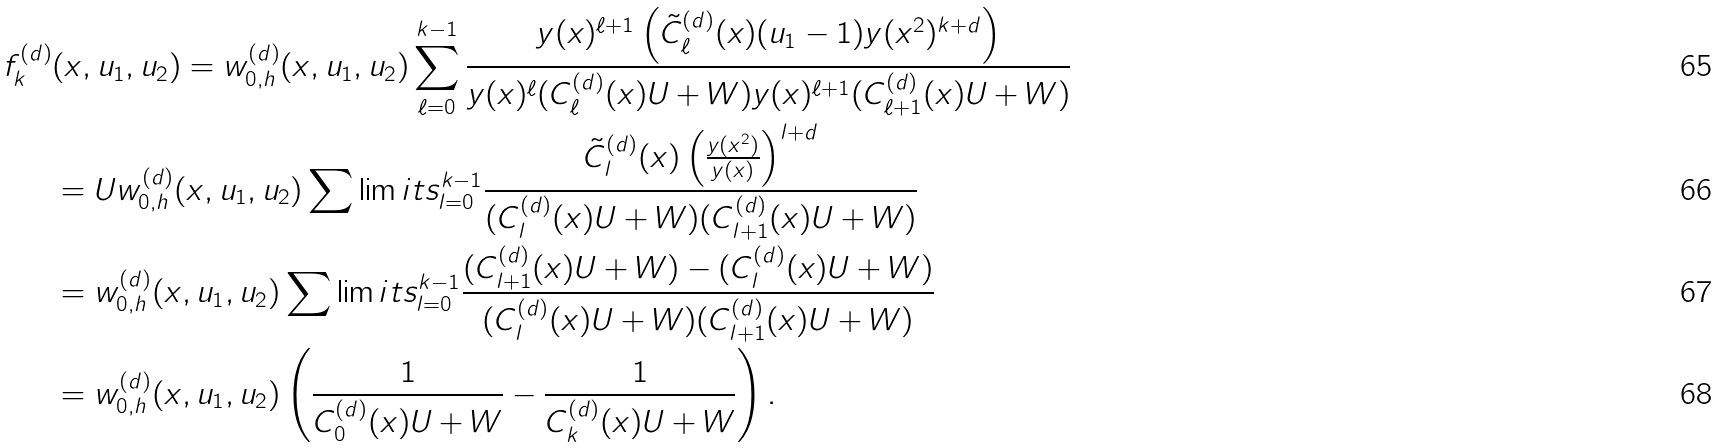<formula> <loc_0><loc_0><loc_500><loc_500>f _ { k } ^ { ( d ) } & ( x , u _ { 1 } , u _ { 2 } ) = w _ { 0 , h } ^ { ( d ) } ( x , u _ { 1 } , u _ { 2 } ) \sum _ { \ell = 0 } ^ { k - 1 } \frac { y ( x ) ^ { \ell + 1 } \left ( \tilde { C } _ { \ell } ^ { ( d ) } ( x ) ( u _ { 1 } - 1 ) y ( x ^ { 2 } ) ^ { k + d } \right ) } { y ( x ) ^ { \ell } ( C _ { \ell } ^ { ( d ) } ( x ) U + W ) y ( x ) ^ { \ell + 1 } ( C _ { \ell + 1 } ^ { ( d ) } ( x ) U + W ) } \\ & = U w _ { 0 , h } ^ { ( d ) } ( x , u _ { 1 } , u _ { 2 } ) \sum \lim i t s _ { l = 0 } ^ { k - 1 } \frac { \tilde { C } _ { l } ^ { ( d ) } ( x ) \left ( \frac { y ( x ^ { 2 } ) } { y ( x ) } \right ) ^ { l + d } } { ( C _ { l } ^ { ( d ) } ( x ) U + W ) ( C _ { l + 1 } ^ { ( d ) } ( x ) U + W ) } \\ & = w _ { 0 , h } ^ { ( d ) } ( x , u _ { 1 } , u _ { 2 } ) \sum \lim i t s _ { l = 0 } ^ { k - 1 } \frac { ( C _ { l + 1 } ^ { ( d ) } ( x ) U + W ) - ( C _ { l } ^ { ( d ) } ( x ) U + W ) } { ( C _ { l } ^ { ( d ) } ( x ) U + W ) ( C _ { l + 1 } ^ { ( d ) } ( x ) U + W ) } \\ & = w _ { 0 , h } ^ { ( d ) } ( x , u _ { 1 } , u _ { 2 } ) \left ( \frac { 1 } { C _ { 0 } ^ { ( d ) } ( x ) U + W } - \frac { 1 } { C _ { k } ^ { ( d ) } ( x ) U + W } \right ) .</formula> 